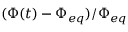Convert formula to latex. <formula><loc_0><loc_0><loc_500><loc_500>( \Phi ( t ) - \Phi _ { e q } ) / \Phi _ { e q }</formula> 